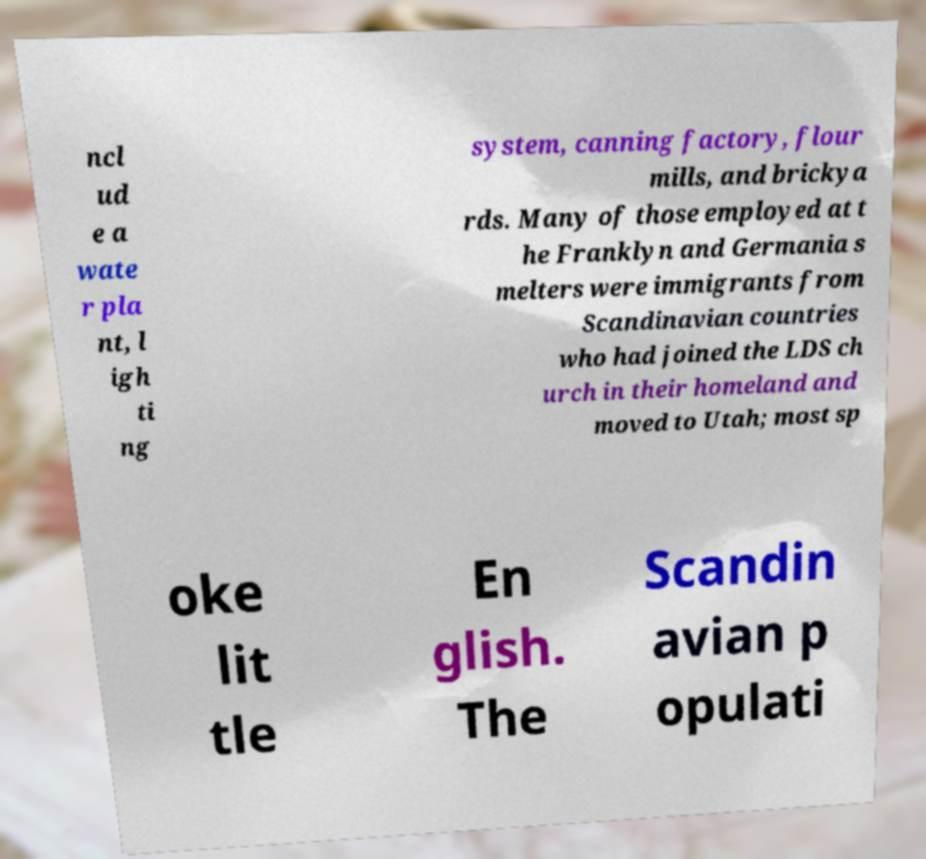Can you accurately transcribe the text from the provided image for me? ncl ud e a wate r pla nt, l igh ti ng system, canning factory, flour mills, and brickya rds. Many of those employed at t he Franklyn and Germania s melters were immigrants from Scandinavian countries who had joined the LDS ch urch in their homeland and moved to Utah; most sp oke lit tle En glish. The Scandin avian p opulati 